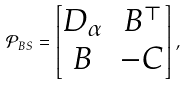<formula> <loc_0><loc_0><loc_500><loc_500>\mathcal { P } _ { B S } = \begin{bmatrix} D _ { \alpha } & B ^ { \top } \\ B & - C \end{bmatrix} ,</formula> 